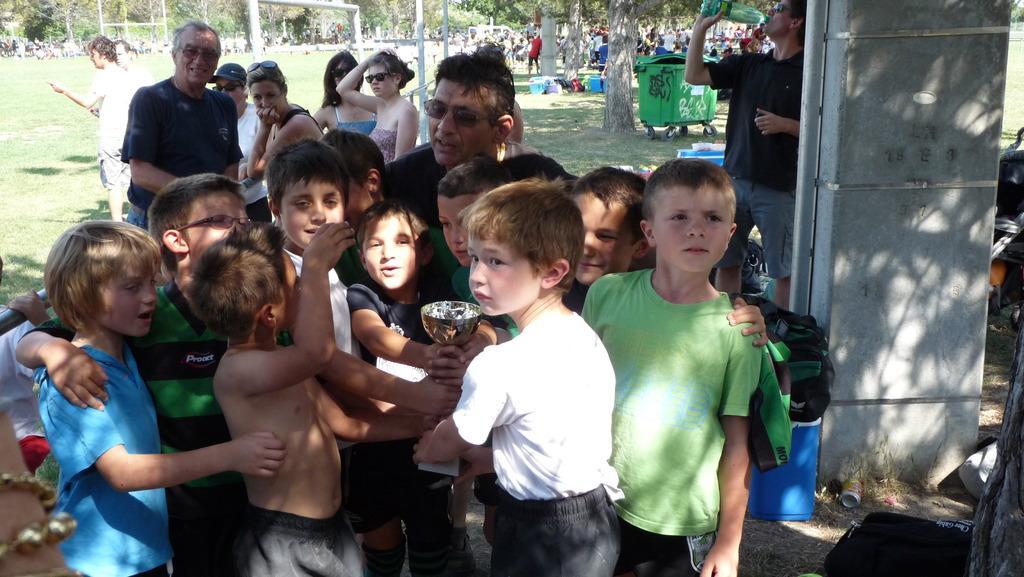Please provide a concise description of this image. Here I can see few children standing and holding a trophy in their hands. At the back few people are standing and smiling by looking at these children. On the right side there is a pillar. At the bottom few objects are placed on the ground. Behind the pillar there is a man standing, holding a bottle in the hand and drinking the water. In the background, I can see a crowd of people on the ground and there are many trees and poles. On the ground, I can see the grass. 